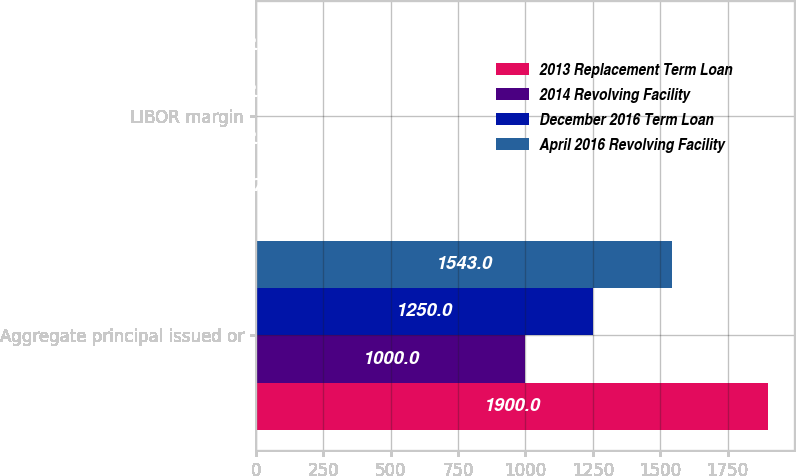<chart> <loc_0><loc_0><loc_500><loc_500><stacked_bar_chart><ecel><fcel>Aggregate principal issued or<fcel>LIBOR margin<nl><fcel>2013 Replacement Term Loan<fcel>1900<fcel>1.75<nl><fcel>2014 Revolving Facility<fcel>1000<fcel>2<nl><fcel>December 2016 Term Loan<fcel>1250<fcel>2<nl><fcel>April 2016 Revolving Facility<fcel>1543<fcel>2<nl></chart> 